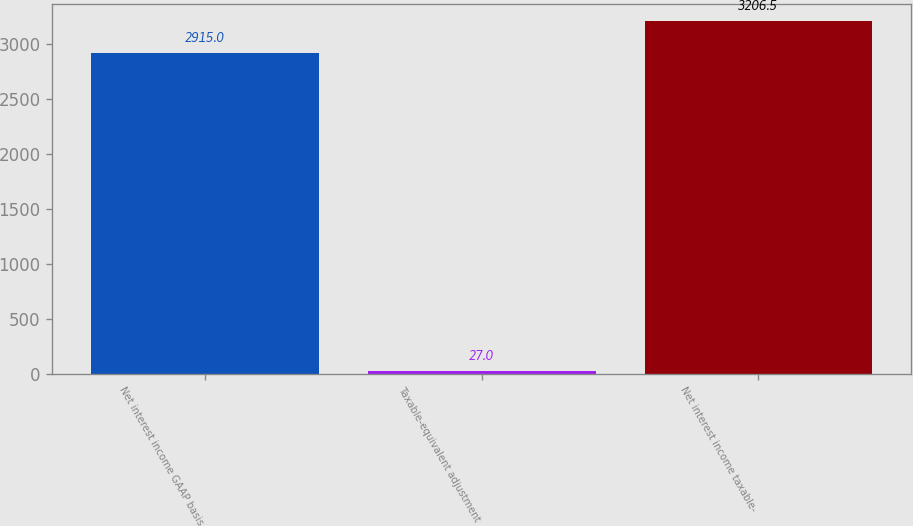<chart> <loc_0><loc_0><loc_500><loc_500><bar_chart><fcel>Net interest income GAAP basis<fcel>Taxable-equivalent adjustment<fcel>Net interest income taxable-<nl><fcel>2915<fcel>27<fcel>3206.5<nl></chart> 